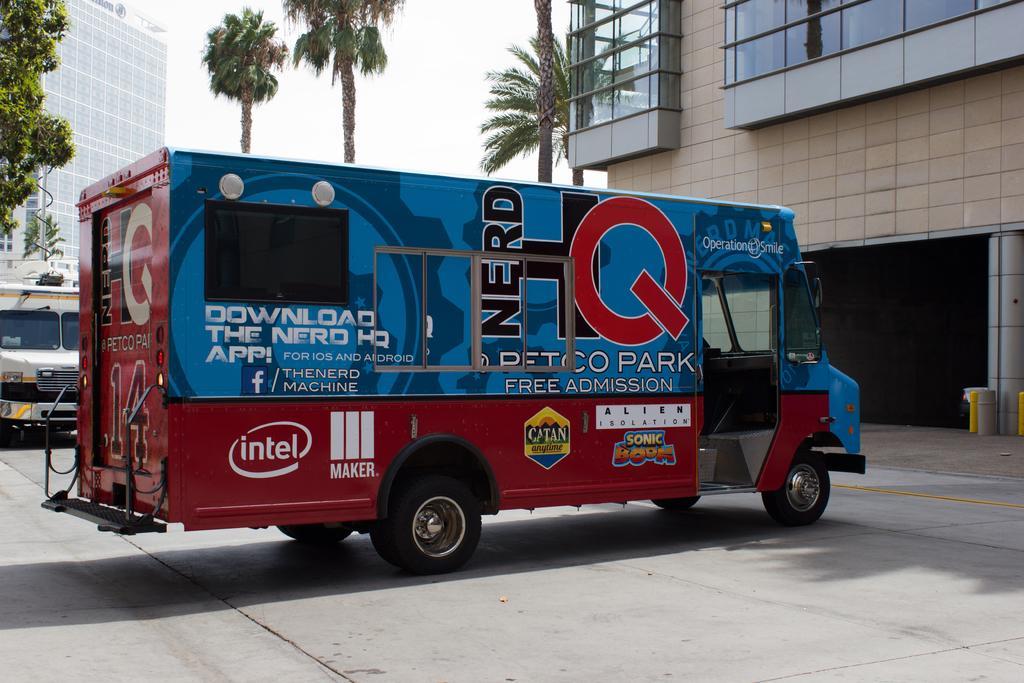Please provide a concise description of this image. In this image, we can see a vehicle is parked on the road. Background we can see buildings, walls, glass objects, trees, vehicle, pillars and sky. 